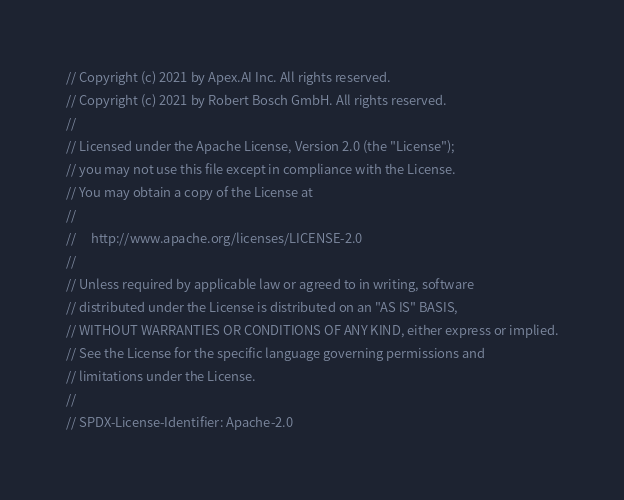<code> <loc_0><loc_0><loc_500><loc_500><_C++_>// Copyright (c) 2021 by Apex.AI Inc. All rights reserved.
// Copyright (c) 2021 by Robert Bosch GmbH. All rights reserved.
//
// Licensed under the Apache License, Version 2.0 (the "License");
// you may not use this file except in compliance with the License.
// You may obtain a copy of the License at
//
//     http://www.apache.org/licenses/LICENSE-2.0
//
// Unless required by applicable law or agreed to in writing, software
// distributed under the License is distributed on an "AS IS" BASIS,
// WITHOUT WARRANTIES OR CONDITIONS OF ANY KIND, either express or implied.
// See the License for the specific language governing permissions and
// limitations under the License.
//
// SPDX-License-Identifier: Apache-2.0
</code> 